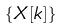<formula> <loc_0><loc_0><loc_500><loc_500>\{ X [ k ] \}</formula> 